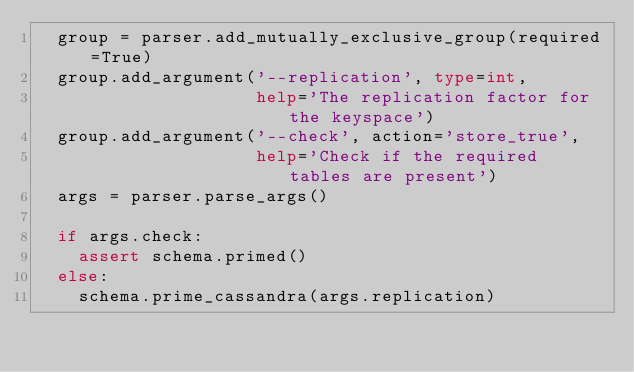Convert code to text. <code><loc_0><loc_0><loc_500><loc_500><_Python_>  group = parser.add_mutually_exclusive_group(required=True)
  group.add_argument('--replication', type=int,
                     help='The replication factor for the keyspace')
  group.add_argument('--check', action='store_true',
                     help='Check if the required tables are present')
  args = parser.parse_args()

  if args.check:
    assert schema.primed()
  else:
    schema.prime_cassandra(args.replication)
</code> 